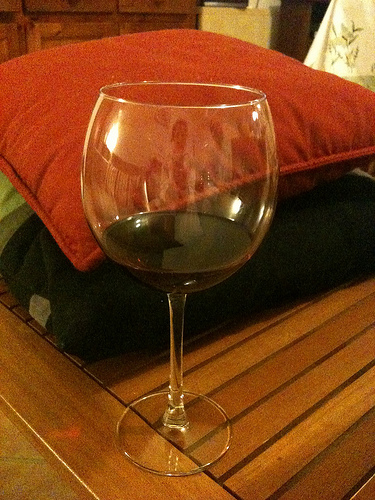<image>
Can you confirm if the glass is next to the pillow? Yes. The glass is positioned adjacent to the pillow, located nearby in the same general area. Is there a pillow behind the glass? Yes. From this viewpoint, the pillow is positioned behind the glass, with the glass partially or fully occluding the pillow. Is there a table on the glass? No. The table is not positioned on the glass. They may be near each other, but the table is not supported by or resting on top of the glass. Is there a wine glass in front of the pillow? Yes. The wine glass is positioned in front of the pillow, appearing closer to the camera viewpoint. 